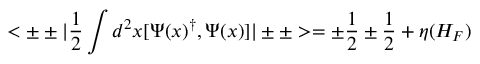Convert formula to latex. <formula><loc_0><loc_0><loc_500><loc_500>< \pm \pm | { \frac { 1 } { 2 } } \int d ^ { 2 } x [ \Psi ( x ) ^ { \dagger } , \Psi ( x ) ] | \pm \pm > = \pm { \frac { 1 } { 2 } } \pm { \frac { 1 } { 2 } } + \eta ( H _ { F } )</formula> 